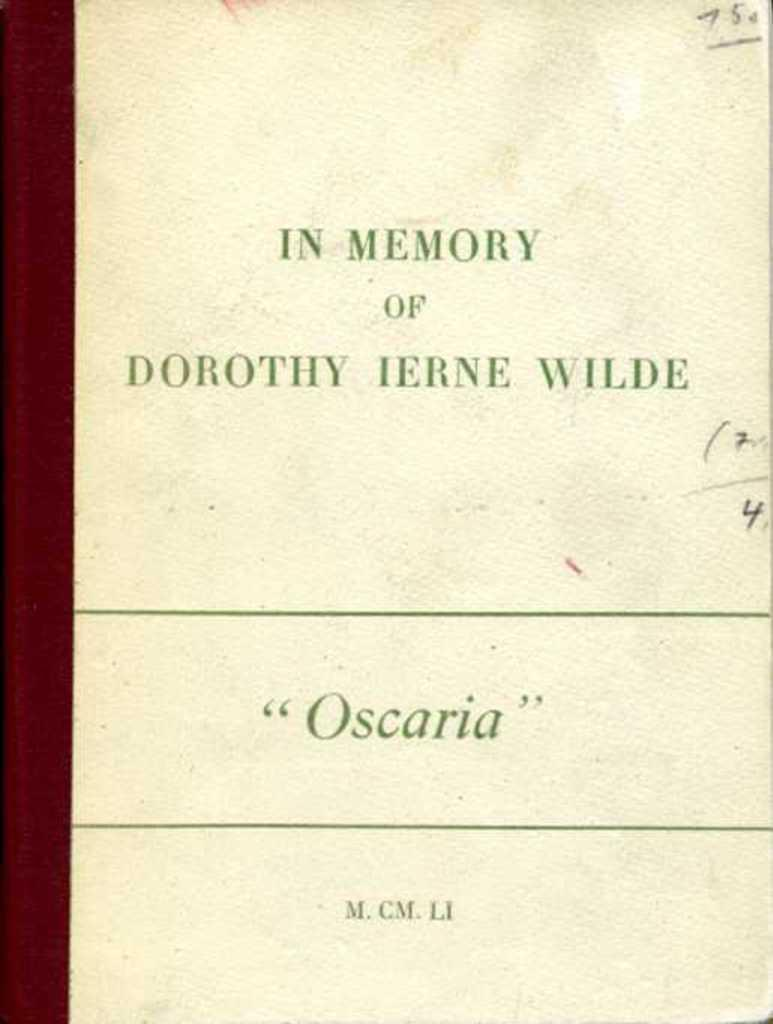<image>
Render a clear and concise summary of the photo. a book that says 'in memory of dorothy ierne wilde' on it 